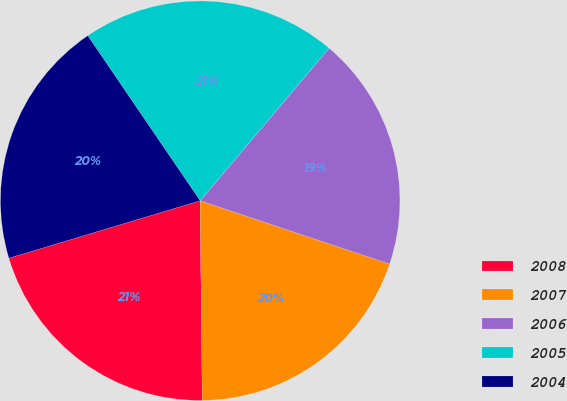<chart> <loc_0><loc_0><loc_500><loc_500><pie_chart><fcel>2008<fcel>2007<fcel>2006<fcel>2005<fcel>2004<nl><fcel>20.52%<fcel>19.7%<fcel>18.97%<fcel>20.68%<fcel>20.13%<nl></chart> 